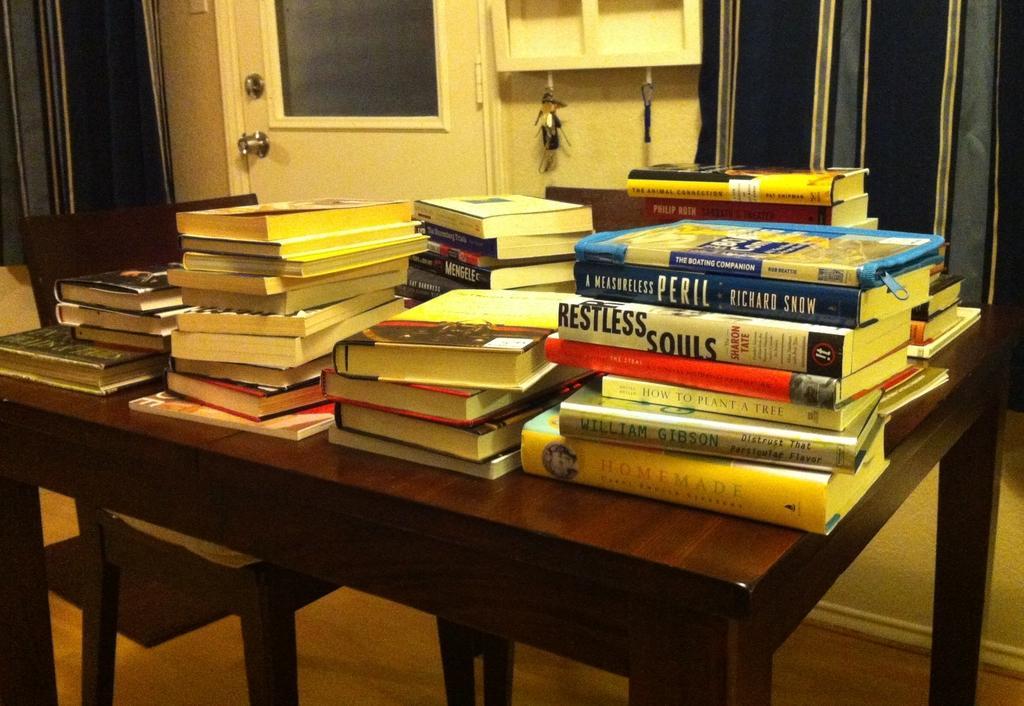Describe this image in one or two sentences. In a picture consists of table, books, chair, door, curtain, keys etc. 